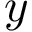<formula> <loc_0><loc_0><loc_500><loc_500>y</formula> 